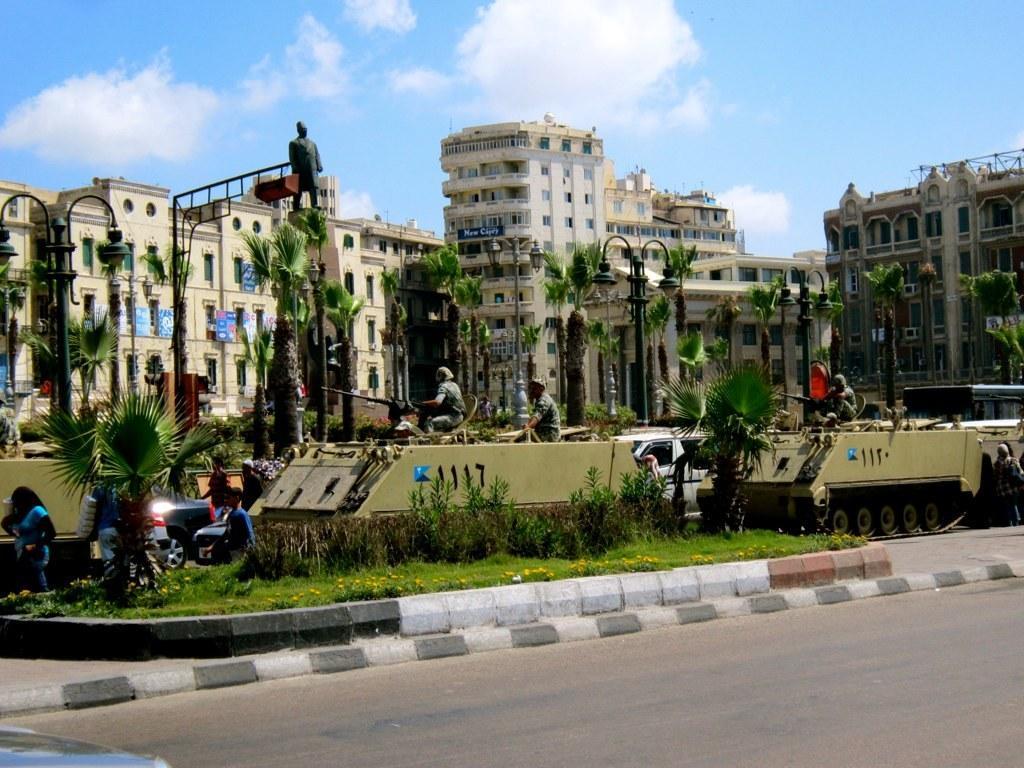Please provide a concise description of this image. In the foreground I can see fence, flowering plants, a group of people on the road and in a train. In the background I can see trees, light poles, buildings, statues and the sky. This image is taken, may be during a day. 